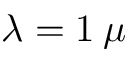<formula> <loc_0><loc_0><loc_500><loc_500>\lambda = 1 \, \mu</formula> 